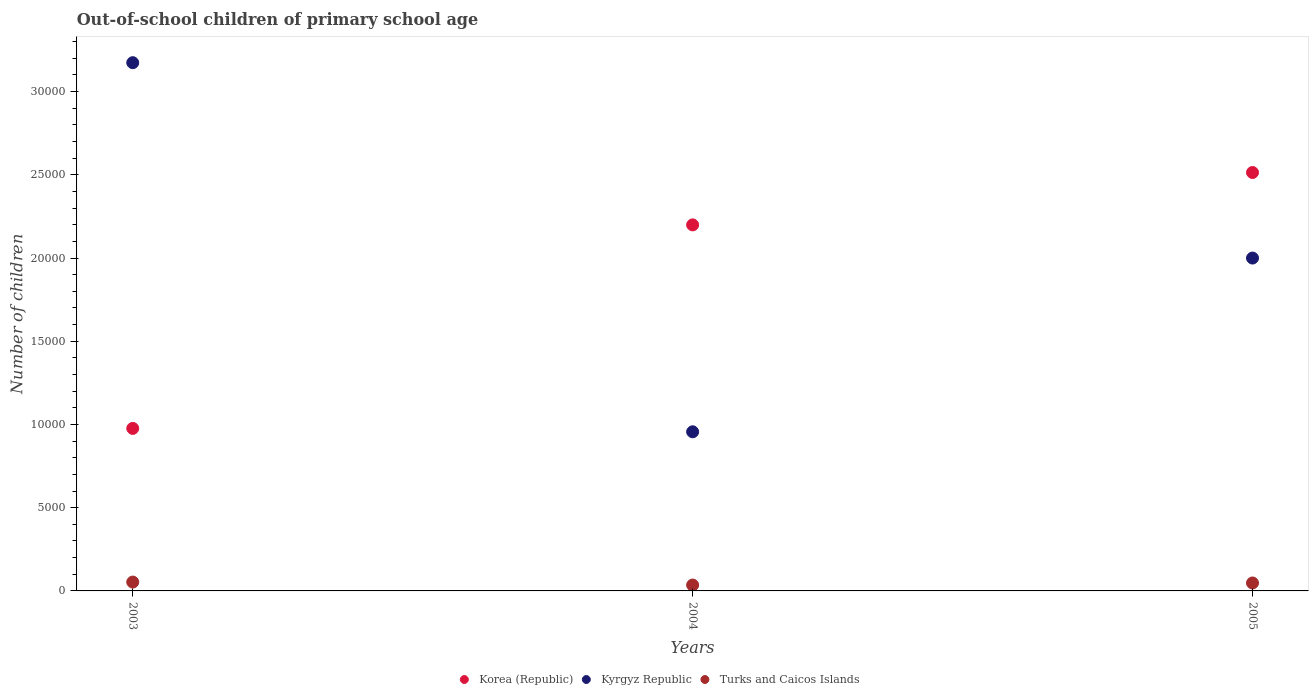Is the number of dotlines equal to the number of legend labels?
Your answer should be compact. Yes. What is the number of out-of-school children in Korea (Republic) in 2005?
Provide a short and direct response. 2.51e+04. Across all years, what is the maximum number of out-of-school children in Kyrgyz Republic?
Your response must be concise. 3.17e+04. Across all years, what is the minimum number of out-of-school children in Kyrgyz Republic?
Ensure brevity in your answer.  9560. In which year was the number of out-of-school children in Korea (Republic) maximum?
Give a very brief answer. 2005. What is the total number of out-of-school children in Korea (Republic) in the graph?
Provide a short and direct response. 5.69e+04. What is the difference between the number of out-of-school children in Korea (Republic) in 2004 and that in 2005?
Give a very brief answer. -3147. What is the difference between the number of out-of-school children in Kyrgyz Republic in 2003 and the number of out-of-school children in Turks and Caicos Islands in 2005?
Ensure brevity in your answer.  3.13e+04. What is the average number of out-of-school children in Turks and Caicos Islands per year?
Your answer should be compact. 454. In the year 2004, what is the difference between the number of out-of-school children in Turks and Caicos Islands and number of out-of-school children in Korea (Republic)?
Your answer should be compact. -2.16e+04. What is the ratio of the number of out-of-school children in Kyrgyz Republic in 2003 to that in 2005?
Make the answer very short. 1.59. Is the number of out-of-school children in Turks and Caicos Islands in 2003 less than that in 2004?
Make the answer very short. No. What is the difference between the highest and the second highest number of out-of-school children in Kyrgyz Republic?
Provide a succinct answer. 1.17e+04. What is the difference between the highest and the lowest number of out-of-school children in Korea (Republic)?
Provide a short and direct response. 1.54e+04. Does the number of out-of-school children in Korea (Republic) monotonically increase over the years?
Ensure brevity in your answer.  Yes. How many dotlines are there?
Make the answer very short. 3. What is the difference between two consecutive major ticks on the Y-axis?
Your answer should be very brief. 5000. Does the graph contain any zero values?
Make the answer very short. No. Where does the legend appear in the graph?
Give a very brief answer. Bottom center. How many legend labels are there?
Give a very brief answer. 3. What is the title of the graph?
Provide a succinct answer. Out-of-school children of primary school age. What is the label or title of the X-axis?
Offer a terse response. Years. What is the label or title of the Y-axis?
Offer a terse response. Number of children. What is the Number of children of Korea (Republic) in 2003?
Your answer should be very brief. 9763. What is the Number of children of Kyrgyz Republic in 2003?
Your answer should be very brief. 3.17e+04. What is the Number of children of Turks and Caicos Islands in 2003?
Provide a succinct answer. 532. What is the Number of children in Korea (Republic) in 2004?
Provide a short and direct response. 2.20e+04. What is the Number of children of Kyrgyz Republic in 2004?
Offer a very short reply. 9560. What is the Number of children of Turks and Caicos Islands in 2004?
Give a very brief answer. 353. What is the Number of children of Korea (Republic) in 2005?
Your answer should be very brief. 2.51e+04. What is the Number of children of Kyrgyz Republic in 2005?
Offer a very short reply. 2.00e+04. What is the Number of children in Turks and Caicos Islands in 2005?
Your response must be concise. 477. Across all years, what is the maximum Number of children of Korea (Republic)?
Provide a succinct answer. 2.51e+04. Across all years, what is the maximum Number of children of Kyrgyz Republic?
Provide a succinct answer. 3.17e+04. Across all years, what is the maximum Number of children of Turks and Caicos Islands?
Provide a succinct answer. 532. Across all years, what is the minimum Number of children of Korea (Republic)?
Your response must be concise. 9763. Across all years, what is the minimum Number of children in Kyrgyz Republic?
Your answer should be compact. 9560. Across all years, what is the minimum Number of children in Turks and Caicos Islands?
Your answer should be compact. 353. What is the total Number of children in Korea (Republic) in the graph?
Your answer should be very brief. 5.69e+04. What is the total Number of children in Kyrgyz Republic in the graph?
Provide a succinct answer. 6.13e+04. What is the total Number of children in Turks and Caicos Islands in the graph?
Offer a very short reply. 1362. What is the difference between the Number of children of Korea (Republic) in 2003 and that in 2004?
Ensure brevity in your answer.  -1.22e+04. What is the difference between the Number of children of Kyrgyz Republic in 2003 and that in 2004?
Ensure brevity in your answer.  2.22e+04. What is the difference between the Number of children in Turks and Caicos Islands in 2003 and that in 2004?
Your answer should be compact. 179. What is the difference between the Number of children of Korea (Republic) in 2003 and that in 2005?
Give a very brief answer. -1.54e+04. What is the difference between the Number of children in Kyrgyz Republic in 2003 and that in 2005?
Offer a terse response. 1.17e+04. What is the difference between the Number of children in Turks and Caicos Islands in 2003 and that in 2005?
Ensure brevity in your answer.  55. What is the difference between the Number of children in Korea (Republic) in 2004 and that in 2005?
Your answer should be very brief. -3147. What is the difference between the Number of children of Kyrgyz Republic in 2004 and that in 2005?
Make the answer very short. -1.04e+04. What is the difference between the Number of children of Turks and Caicos Islands in 2004 and that in 2005?
Keep it short and to the point. -124. What is the difference between the Number of children of Korea (Republic) in 2003 and the Number of children of Kyrgyz Republic in 2004?
Offer a terse response. 203. What is the difference between the Number of children of Korea (Republic) in 2003 and the Number of children of Turks and Caicos Islands in 2004?
Offer a terse response. 9410. What is the difference between the Number of children in Kyrgyz Republic in 2003 and the Number of children in Turks and Caicos Islands in 2004?
Make the answer very short. 3.14e+04. What is the difference between the Number of children in Korea (Republic) in 2003 and the Number of children in Kyrgyz Republic in 2005?
Ensure brevity in your answer.  -1.02e+04. What is the difference between the Number of children in Korea (Republic) in 2003 and the Number of children in Turks and Caicos Islands in 2005?
Your answer should be compact. 9286. What is the difference between the Number of children of Kyrgyz Republic in 2003 and the Number of children of Turks and Caicos Islands in 2005?
Ensure brevity in your answer.  3.13e+04. What is the difference between the Number of children of Korea (Republic) in 2004 and the Number of children of Kyrgyz Republic in 2005?
Offer a terse response. 1993. What is the difference between the Number of children in Korea (Republic) in 2004 and the Number of children in Turks and Caicos Islands in 2005?
Give a very brief answer. 2.15e+04. What is the difference between the Number of children in Kyrgyz Republic in 2004 and the Number of children in Turks and Caicos Islands in 2005?
Offer a very short reply. 9083. What is the average Number of children of Korea (Republic) per year?
Your answer should be very brief. 1.90e+04. What is the average Number of children in Kyrgyz Republic per year?
Offer a very short reply. 2.04e+04. What is the average Number of children in Turks and Caicos Islands per year?
Your response must be concise. 454. In the year 2003, what is the difference between the Number of children of Korea (Republic) and Number of children of Kyrgyz Republic?
Your answer should be compact. -2.20e+04. In the year 2003, what is the difference between the Number of children in Korea (Republic) and Number of children in Turks and Caicos Islands?
Ensure brevity in your answer.  9231. In the year 2003, what is the difference between the Number of children in Kyrgyz Republic and Number of children in Turks and Caicos Islands?
Give a very brief answer. 3.12e+04. In the year 2004, what is the difference between the Number of children in Korea (Republic) and Number of children in Kyrgyz Republic?
Your answer should be compact. 1.24e+04. In the year 2004, what is the difference between the Number of children in Korea (Republic) and Number of children in Turks and Caicos Islands?
Ensure brevity in your answer.  2.16e+04. In the year 2004, what is the difference between the Number of children of Kyrgyz Republic and Number of children of Turks and Caicos Islands?
Keep it short and to the point. 9207. In the year 2005, what is the difference between the Number of children of Korea (Republic) and Number of children of Kyrgyz Republic?
Your answer should be compact. 5140. In the year 2005, what is the difference between the Number of children of Korea (Republic) and Number of children of Turks and Caicos Islands?
Your response must be concise. 2.47e+04. In the year 2005, what is the difference between the Number of children in Kyrgyz Republic and Number of children in Turks and Caicos Islands?
Your answer should be very brief. 1.95e+04. What is the ratio of the Number of children in Korea (Republic) in 2003 to that in 2004?
Your response must be concise. 0.44. What is the ratio of the Number of children in Kyrgyz Republic in 2003 to that in 2004?
Offer a terse response. 3.32. What is the ratio of the Number of children of Turks and Caicos Islands in 2003 to that in 2004?
Ensure brevity in your answer.  1.51. What is the ratio of the Number of children in Korea (Republic) in 2003 to that in 2005?
Your answer should be very brief. 0.39. What is the ratio of the Number of children of Kyrgyz Republic in 2003 to that in 2005?
Keep it short and to the point. 1.59. What is the ratio of the Number of children in Turks and Caicos Islands in 2003 to that in 2005?
Offer a very short reply. 1.12. What is the ratio of the Number of children in Korea (Republic) in 2004 to that in 2005?
Keep it short and to the point. 0.87. What is the ratio of the Number of children in Kyrgyz Republic in 2004 to that in 2005?
Your answer should be very brief. 0.48. What is the ratio of the Number of children of Turks and Caicos Islands in 2004 to that in 2005?
Ensure brevity in your answer.  0.74. What is the difference between the highest and the second highest Number of children of Korea (Republic)?
Ensure brevity in your answer.  3147. What is the difference between the highest and the second highest Number of children in Kyrgyz Republic?
Your response must be concise. 1.17e+04. What is the difference between the highest and the second highest Number of children of Turks and Caicos Islands?
Provide a short and direct response. 55. What is the difference between the highest and the lowest Number of children of Korea (Republic)?
Provide a short and direct response. 1.54e+04. What is the difference between the highest and the lowest Number of children in Kyrgyz Republic?
Offer a very short reply. 2.22e+04. What is the difference between the highest and the lowest Number of children in Turks and Caicos Islands?
Give a very brief answer. 179. 